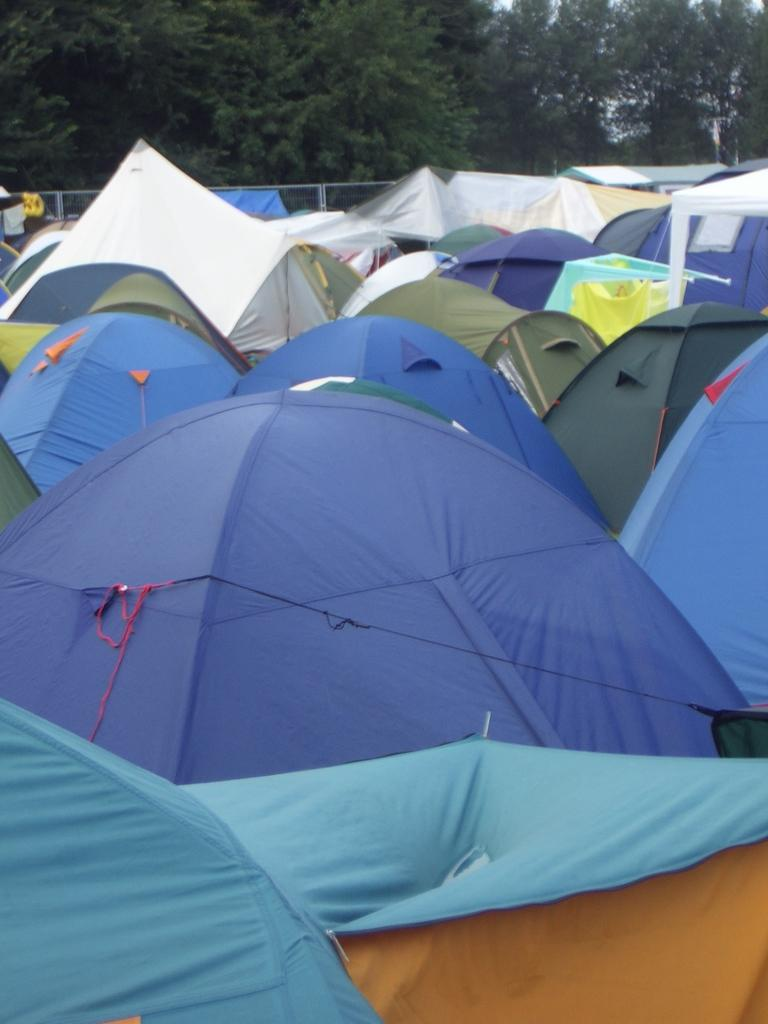What type of structures are present in the image? There are tents in the image. What colors are the tents? The tents are green, blue, and white in color. What can be seen in the background of the image? There are trees in the background of the image. What type of oil is being used to fuel the horses in the image? There are no horses present in the image, so there is no oil being used to fuel them. 